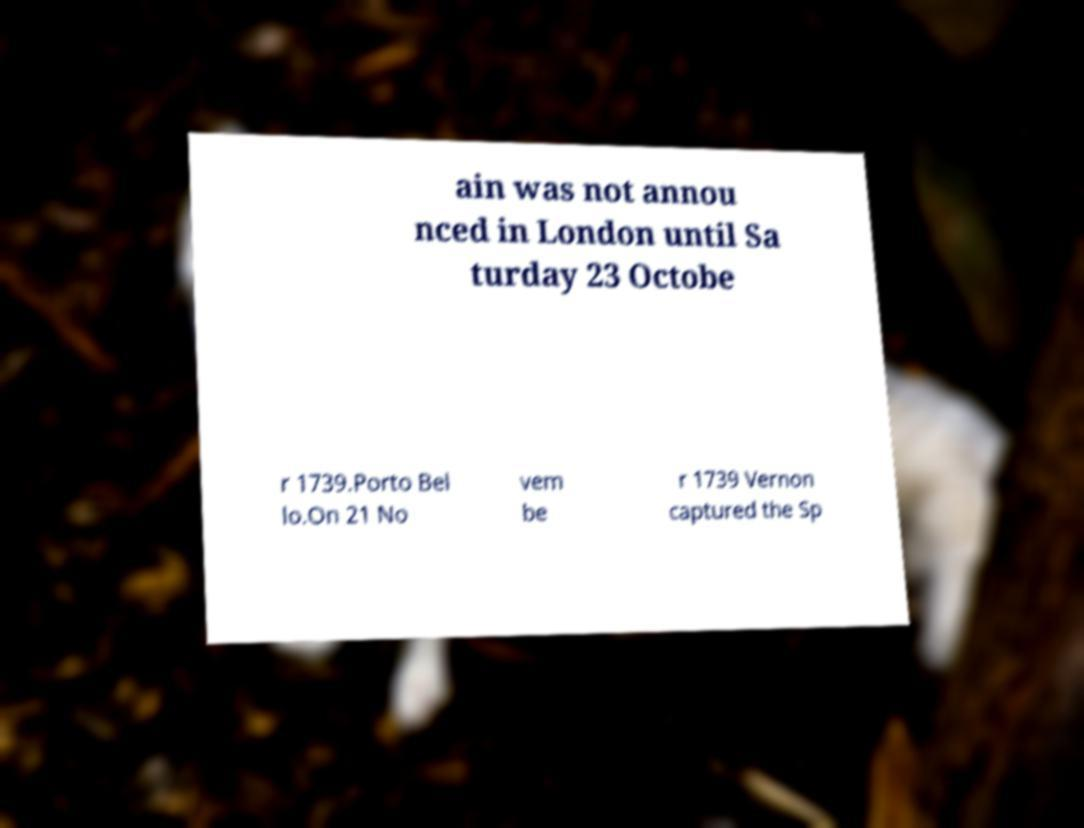Can you read and provide the text displayed in the image?This photo seems to have some interesting text. Can you extract and type it out for me? ain was not annou nced in London until Sa turday 23 Octobe r 1739.Porto Bel lo.On 21 No vem be r 1739 Vernon captured the Sp 